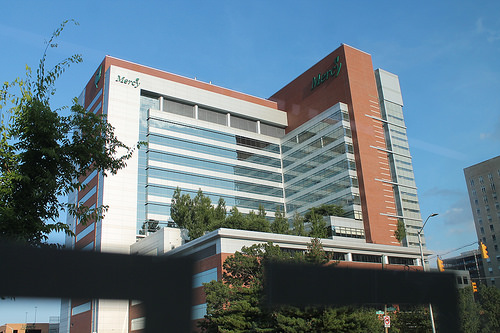<image>
Is the tree under the building? No. The tree is not positioned under the building. The vertical relationship between these objects is different. 